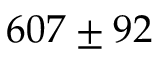Convert formula to latex. <formula><loc_0><loc_0><loc_500><loc_500>6 0 7 \pm 9 2</formula> 